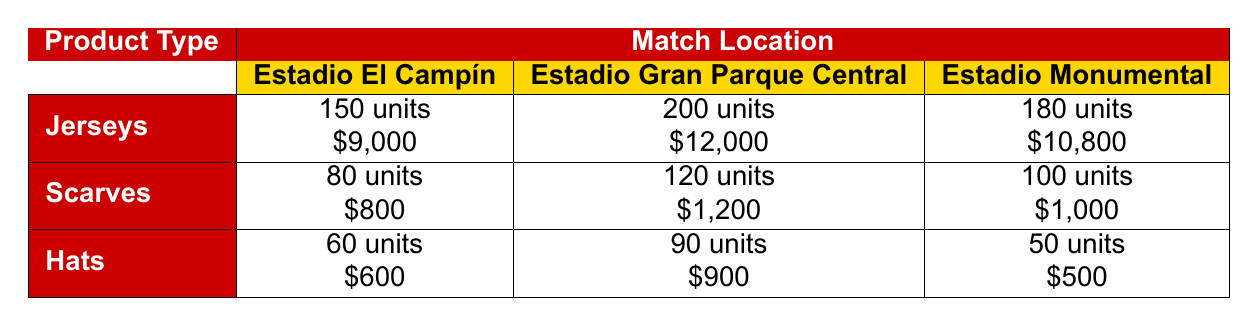What is the total revenue generated from selling jerseys at Estadio Gran Parque Central? From the table, the total revenue from selling jerseys at Estadio Gran Parque Central is listed as $12,000.
Answer: $12,000 How many scarves were sold at Estadio El Campín? The sales quantity for scarves at Estadio El Campín can be found directly in the table, which states that 80 scarves were sold.
Answer: 80 What is the total sales quantity of hats sold across all match locations? To answer this, we sum the sales quantities of hats from each location: 60 (Estadio El Campín) + 90 (Estadio Gran Parque Central) + 50 (Estadio Monumental) = 200.
Answer: 200 Did Estadio Monumental generate more revenue from jerseys than from scarves? Looking at the total revenue listed in the table, Estadio Monumental generated $10,800 from jerseys and $1,000 from scarves. Since $10,800 is greater than $1,000, the statement is true.
Answer: Yes Which match location had the highest revenue from merchandise sales? By examining the total revenues for each location: Estadio El Campín ($9,800), Estadio Gran Parque Central ($14,100), and Estadio Monumental ($11,300), we see that Estadio Gran Parque Central has the highest revenue.
Answer: Estadio Gran Parque Central What was the average number of scarves sold at Estadio El Campín and Estadio Monumental? To find the average, we first add the scarves sold: 80 (Estadio El Campín) + 100 (Estadio Monumental) = 180. Then, we divide by the number of locations, which is 2: 180 / 2 = 90.
Answer: 90 How much total revenue was generated from selling hats at Estadio Gran Parque Central? The table provides the total revenue from selling hats at Estadio Gran Parque Central, which is recorded as $900.
Answer: $900 What is the difference in sales quantity of jerseys between Estadio El Campín and Estadio Monumental? The sales quantity for jerseys at Estadio El Campín is 150 and at Estadio Monumental is 180. The difference is calculated as 180 - 150 = 30.
Answer: 30 How many total units of merchandise were sold at Estadio El Campín? To find this, we sum the sales quantities for all merchandise types sold at Estadio El Campín: 150 (jerseys) + 80 (scarves) + 60 (hats) = 290.
Answer: 290 